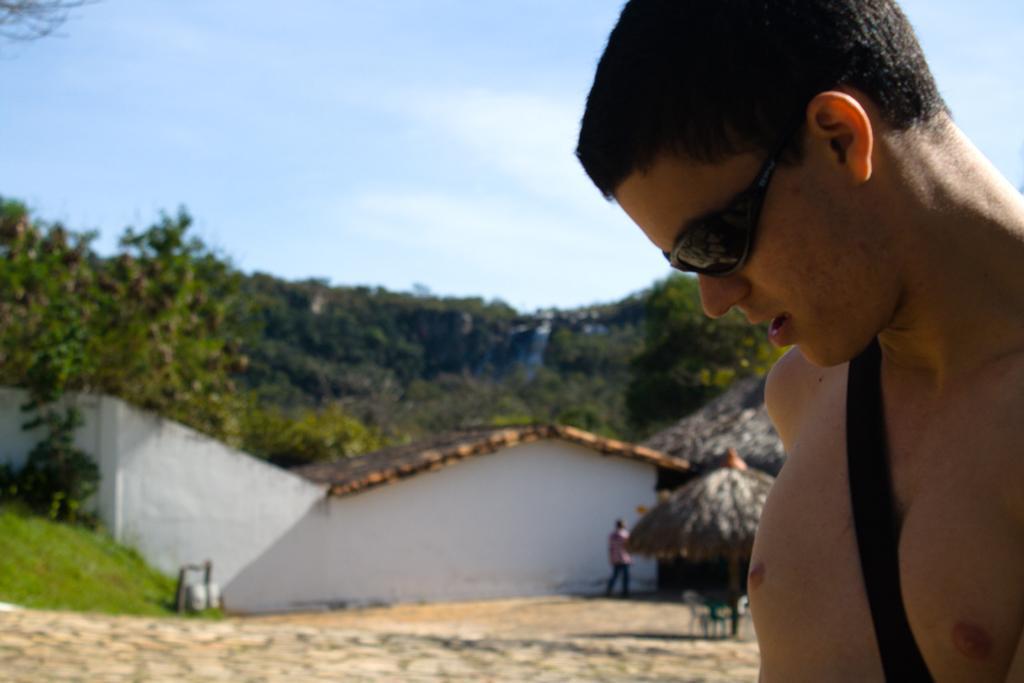Can you describe this image briefly? In this image, there are a few people. Among them, we can see a person wearing spectacles. We can see the ground with some objects. We can see some grass, plants and trees. We can also see some houses. We can see the shed and some chairs. We can also see the sky. 